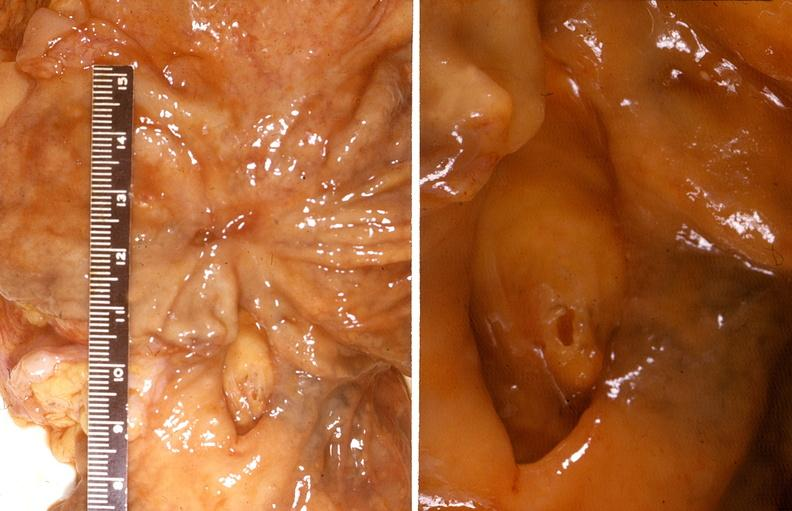what is present?
Answer the question using a single word or phrase. Gastrointestinal 